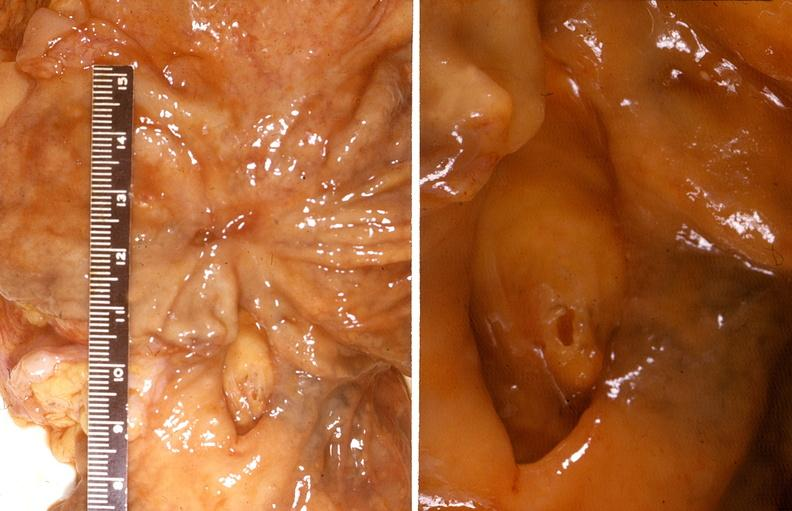what is present?
Answer the question using a single word or phrase. Gastrointestinal 